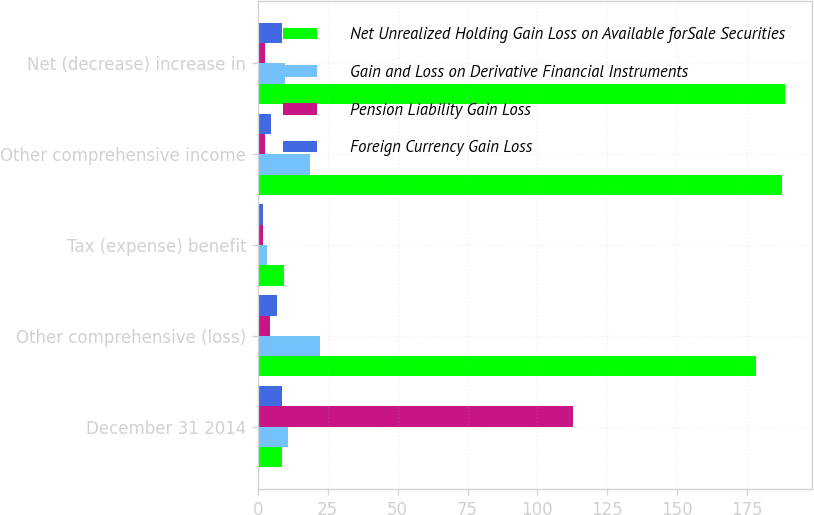Convert chart. <chart><loc_0><loc_0><loc_500><loc_500><stacked_bar_chart><ecel><fcel>December 31 2014<fcel>Other comprehensive (loss)<fcel>Tax (expense) benefit<fcel>Other comprehensive income<fcel>Net (decrease) increase in<nl><fcel>Net Unrealized Holding Gain Loss on Available forSale Securities<fcel>8.5<fcel>178<fcel>9.5<fcel>187.5<fcel>188.7<nl><fcel>Gain and Loss on Derivative Financial Instruments<fcel>10.8<fcel>22.1<fcel>3.3<fcel>18.8<fcel>9.6<nl><fcel>Pension Liability Gain Loss<fcel>112.7<fcel>4.5<fcel>2<fcel>2.5<fcel>2.5<nl><fcel>Foreign Currency Gain Loss<fcel>8.5<fcel>6.8<fcel>2<fcel>4.8<fcel>8.5<nl></chart> 